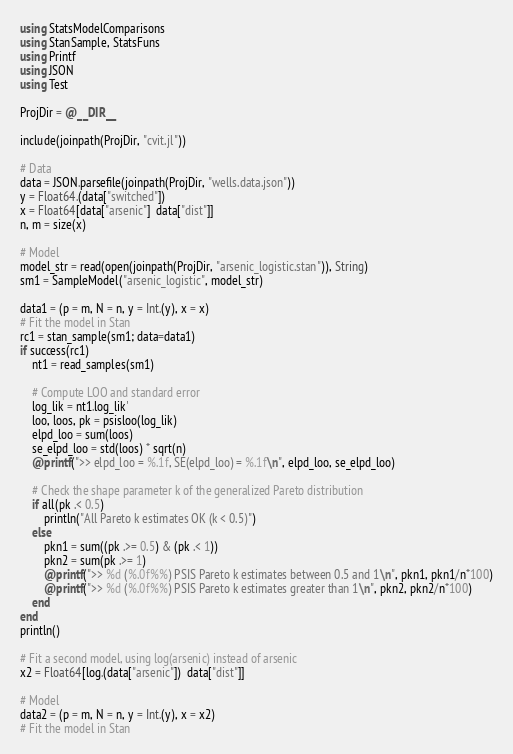<code> <loc_0><loc_0><loc_500><loc_500><_Julia_>using StatsModelComparisons
using StanSample, StatsFuns
using Printf
using JSON
using Test

ProjDir = @__DIR__

include(joinpath(ProjDir, "cvit.jl"))

# Data
data = JSON.parsefile(joinpath(ProjDir, "wells.data.json"))
y = Float64.(data["switched"])
x = Float64[data["arsenic"]  data["dist"]]
n, m = size(x)

# Model
model_str = read(open(joinpath(ProjDir, "arsenic_logistic.stan")), String)
sm1 = SampleModel("arsenic_logistic", model_str)

data1 = (p = m, N = n, y = Int.(y), x = x)
# Fit the model in Stan
rc1 = stan_sample(sm1; data=data1)
if success(rc1)
    nt1 = read_samples(sm1)

    # Compute LOO and standard error
    log_lik = nt1.log_lik'
    loo, loos, pk = psisloo(log_lik)
    elpd_loo = sum(loos)
    se_elpd_loo = std(loos) * sqrt(n)
    @printf(">> elpd_loo = %.1f, SE(elpd_loo) = %.1f\n", elpd_loo, se_elpd_loo)

    # Check the shape parameter k of the generalized Pareto distribution
    if all(pk .< 0.5)
        println("All Pareto k estimates OK (k < 0.5)")
    else
        pkn1 = sum((pk .>= 0.5) & (pk .< 1))
        pkn2 = sum(pk .>= 1)
        @printf(">> %d (%.0f%%) PSIS Pareto k estimates between 0.5 and 1\n", pkn1, pkn1/n*100)
        @printf(">> %d (%.0f%%) PSIS Pareto k estimates greater than 1\n", pkn2, pkn2/n*100)
    end
end
println()

# Fit a second model, using log(arsenic) instead of arsenic
x2 = Float64[log.(data["arsenic"])  data["dist"]]

# Model
data2 = (p = m, N = n, y = Int.(y), x = x2)
# Fit the model in Stan</code> 